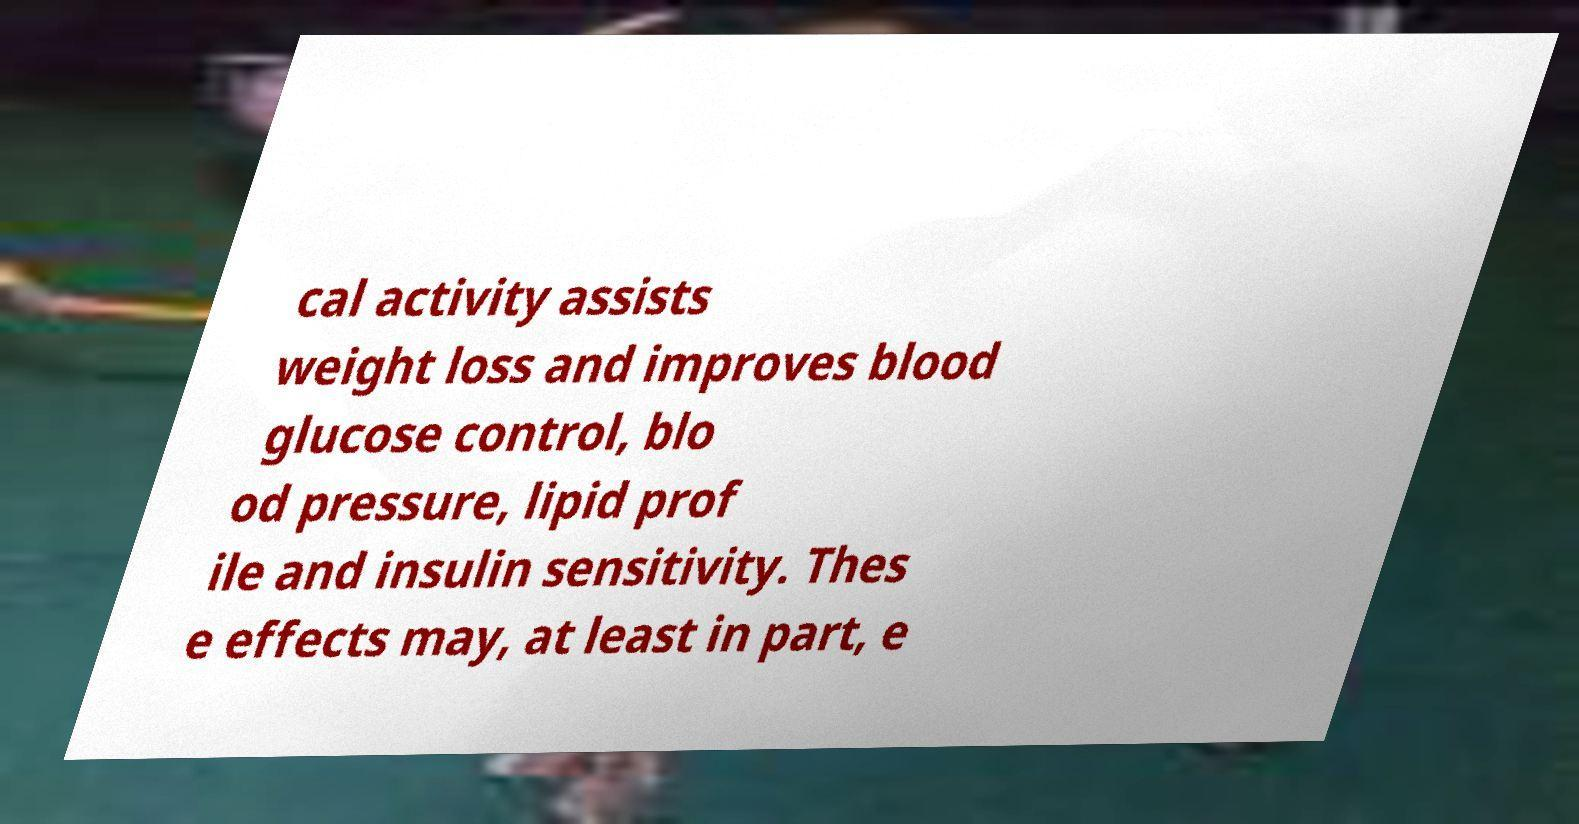I need the written content from this picture converted into text. Can you do that? cal activity assists weight loss and improves blood glucose control, blo od pressure, lipid prof ile and insulin sensitivity. Thes e effects may, at least in part, e 